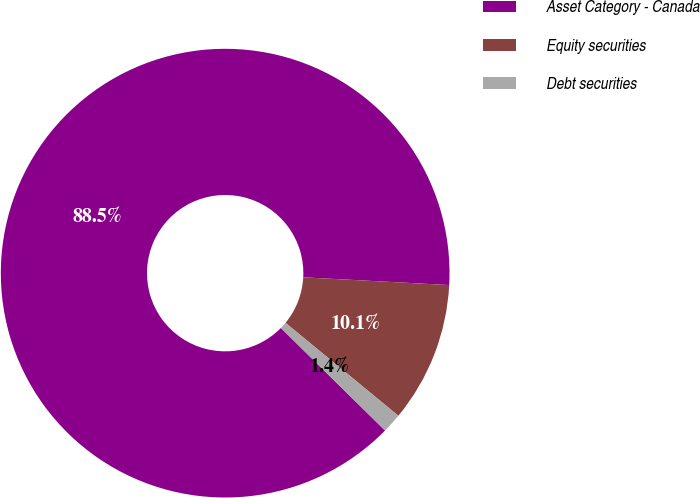Convert chart to OTSL. <chart><loc_0><loc_0><loc_500><loc_500><pie_chart><fcel>Asset Category - Canada<fcel>Equity securities<fcel>Debt securities<nl><fcel>88.47%<fcel>10.12%<fcel>1.41%<nl></chart> 